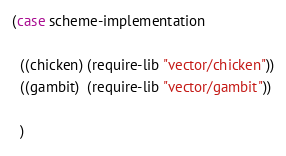Convert code to text. <code><loc_0><loc_0><loc_500><loc_500><_Scheme_>
(case scheme-implementation

  ((chicken) (require-lib "vector/chicken"))
  ((gambit)  (require-lib "vector/gambit"))

  )



</code> 